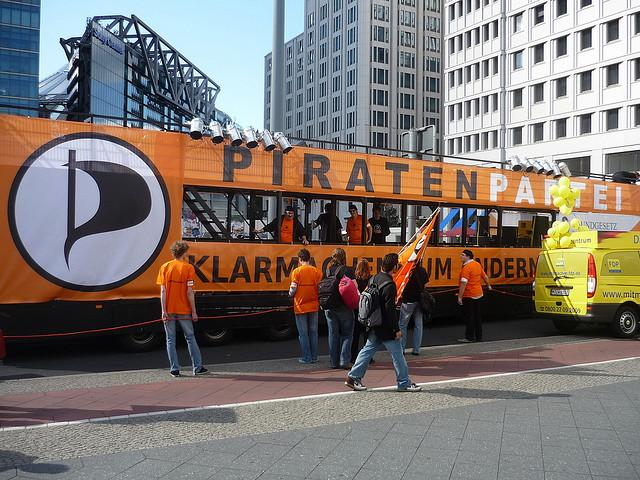Why are the people wearing orange shirts? uniform 